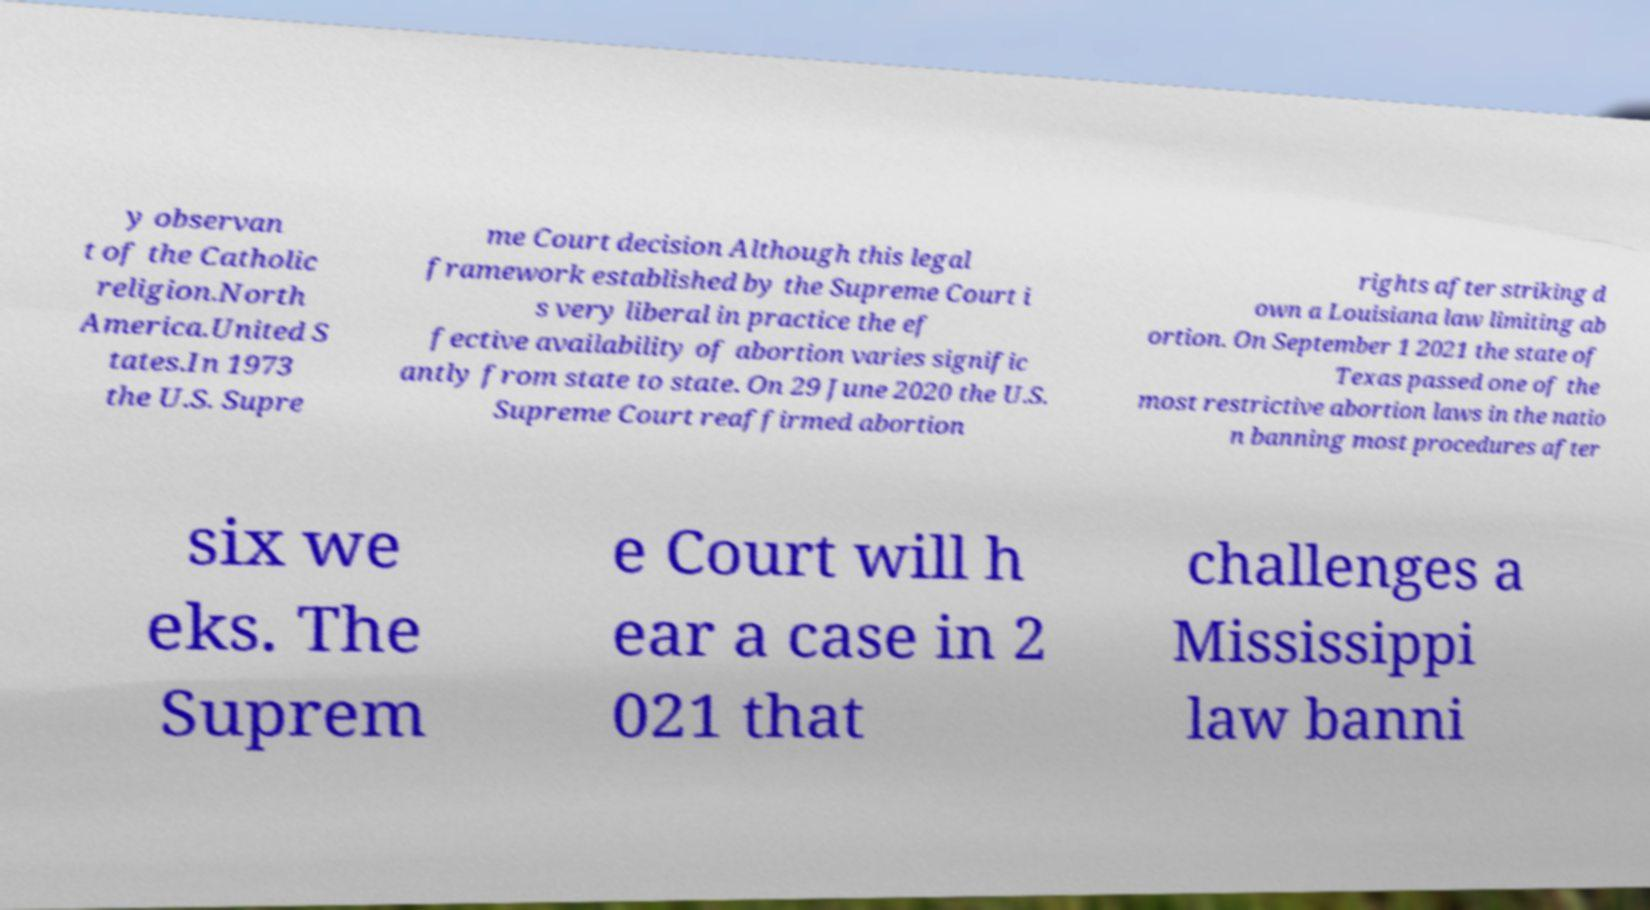Could you extract and type out the text from this image? y observan t of the Catholic religion.North America.United S tates.In 1973 the U.S. Supre me Court decision Although this legal framework established by the Supreme Court i s very liberal in practice the ef fective availability of abortion varies signific antly from state to state. On 29 June 2020 the U.S. Supreme Court reaffirmed abortion rights after striking d own a Louisiana law limiting ab ortion. On September 1 2021 the state of Texas passed one of the most restrictive abortion laws in the natio n banning most procedures after six we eks. The Suprem e Court will h ear a case in 2 021 that challenges a Mississippi law banni 